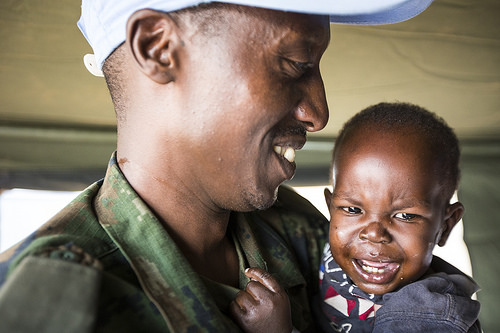<image>
Can you confirm if the man is behind the baby? No. The man is not behind the baby. From this viewpoint, the man appears to be positioned elsewhere in the scene. 